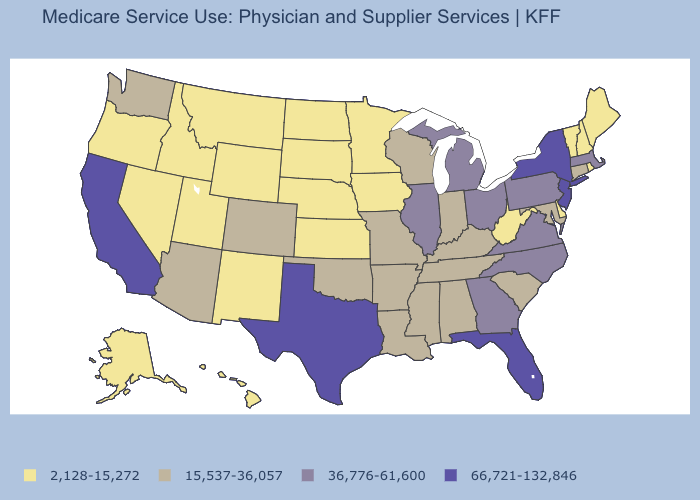What is the value of Mississippi?
Concise answer only. 15,537-36,057. Which states have the highest value in the USA?
Write a very short answer. California, Florida, New Jersey, New York, Texas. Name the states that have a value in the range 15,537-36,057?
Be succinct. Alabama, Arizona, Arkansas, Colorado, Connecticut, Indiana, Kentucky, Louisiana, Maryland, Mississippi, Missouri, Oklahoma, South Carolina, Tennessee, Washington, Wisconsin. What is the value of South Carolina?
Be succinct. 15,537-36,057. Name the states that have a value in the range 15,537-36,057?
Concise answer only. Alabama, Arizona, Arkansas, Colorado, Connecticut, Indiana, Kentucky, Louisiana, Maryland, Mississippi, Missouri, Oklahoma, South Carolina, Tennessee, Washington, Wisconsin. Name the states that have a value in the range 36,776-61,600?
Answer briefly. Georgia, Illinois, Massachusetts, Michigan, North Carolina, Ohio, Pennsylvania, Virginia. What is the lowest value in the West?
Quick response, please. 2,128-15,272. How many symbols are there in the legend?
Give a very brief answer. 4. Name the states that have a value in the range 2,128-15,272?
Short answer required. Alaska, Delaware, Hawaii, Idaho, Iowa, Kansas, Maine, Minnesota, Montana, Nebraska, Nevada, New Hampshire, New Mexico, North Dakota, Oregon, Rhode Island, South Dakota, Utah, Vermont, West Virginia, Wyoming. Does New Jersey have the highest value in the USA?
Answer briefly. Yes. Name the states that have a value in the range 15,537-36,057?
Quick response, please. Alabama, Arizona, Arkansas, Colorado, Connecticut, Indiana, Kentucky, Louisiana, Maryland, Mississippi, Missouri, Oklahoma, South Carolina, Tennessee, Washington, Wisconsin. What is the value of Utah?
Answer briefly. 2,128-15,272. Does the first symbol in the legend represent the smallest category?
Give a very brief answer. Yes. Name the states that have a value in the range 66,721-132,846?
Short answer required. California, Florida, New Jersey, New York, Texas. Does New Hampshire have the same value as Louisiana?
Answer briefly. No. 